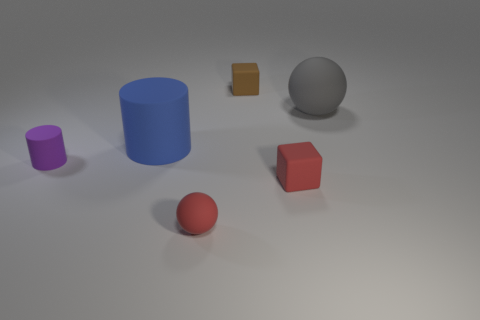What is the size of the ball that is behind the small red thing in front of the tiny red rubber thing to the right of the red ball? The ball located behind the small red object, which is in front of a tiny red item and to the right of the red ball, appears to be of medium size compared to the other objects within the scene. 